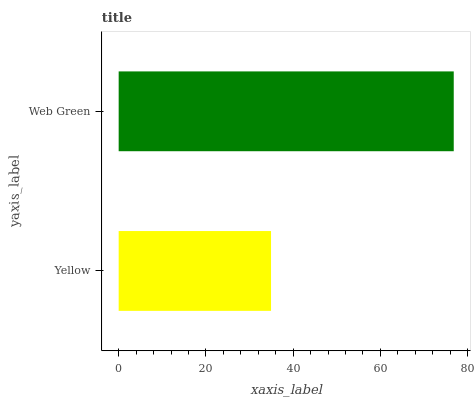Is Yellow the minimum?
Answer yes or no. Yes. Is Web Green the maximum?
Answer yes or no. Yes. Is Web Green the minimum?
Answer yes or no. No. Is Web Green greater than Yellow?
Answer yes or no. Yes. Is Yellow less than Web Green?
Answer yes or no. Yes. Is Yellow greater than Web Green?
Answer yes or no. No. Is Web Green less than Yellow?
Answer yes or no. No. Is Web Green the high median?
Answer yes or no. Yes. Is Yellow the low median?
Answer yes or no. Yes. Is Yellow the high median?
Answer yes or no. No. Is Web Green the low median?
Answer yes or no. No. 